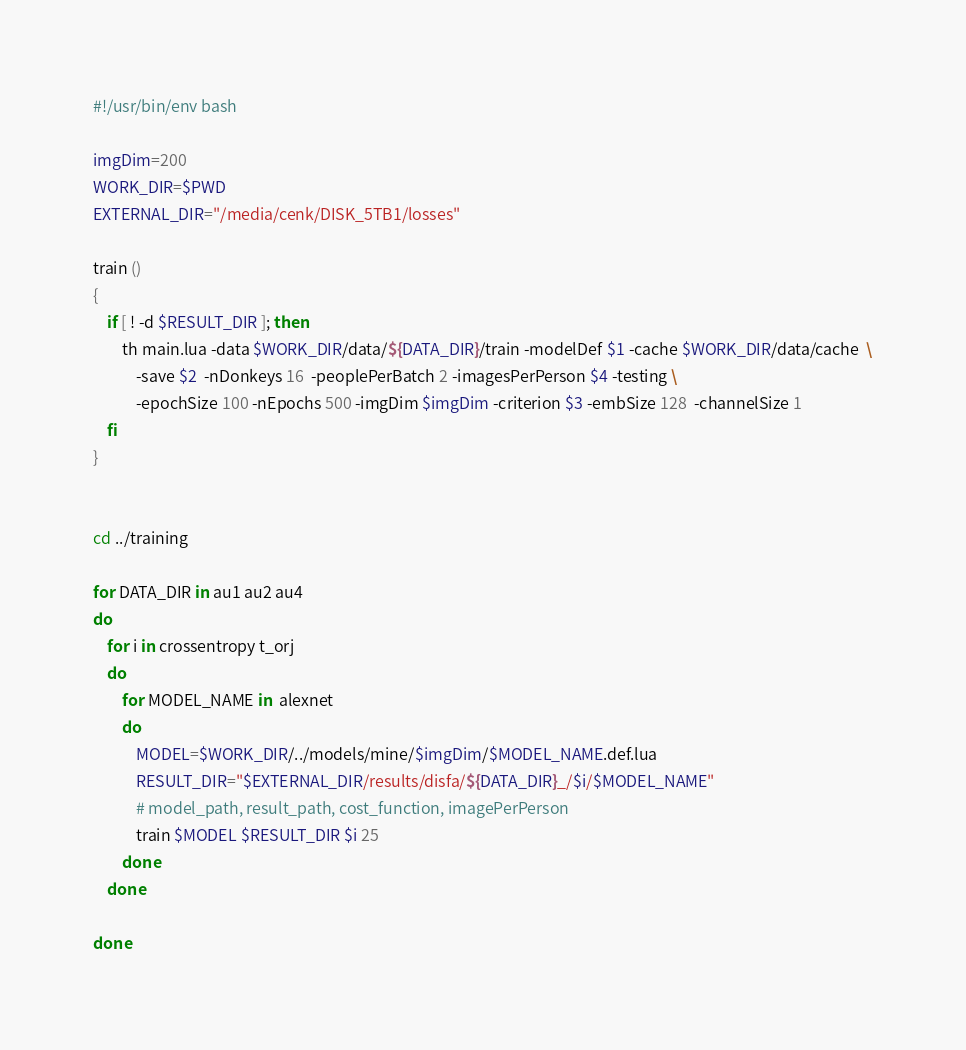Convert code to text. <code><loc_0><loc_0><loc_500><loc_500><_Bash_>#!/usr/bin/env bash

imgDim=200
WORK_DIR=$PWD
EXTERNAL_DIR="/media/cenk/DISK_5TB1/losses"

train ()
{
    if [ ! -d $RESULT_DIR ]; then
        th main.lua -data $WORK_DIR/data/${DATA_DIR}/train -modelDef $1 -cache $WORK_DIR/data/cache  \
            -save $2  -nDonkeys 16  -peoplePerBatch 2 -imagesPerPerson $4 -testing \
            -epochSize 100 -nEpochs 500 -imgDim $imgDim -criterion $3 -embSize 128  -channelSize 1
    fi
}


cd ../training

for DATA_DIR in au1 au2 au4
do
    for i in crossentropy t_orj
    do
        for MODEL_NAME in  alexnet
        do
            MODEL=$WORK_DIR/../models/mine/$imgDim/$MODEL_NAME.def.lua
            RESULT_DIR="$EXTERNAL_DIR/results/disfa/${DATA_DIR}_/$i/$MODEL_NAME"
            # model_path, result_path, cost_function, imagePerPerson
            train $MODEL $RESULT_DIR $i 25
        done
    done

done
</code> 